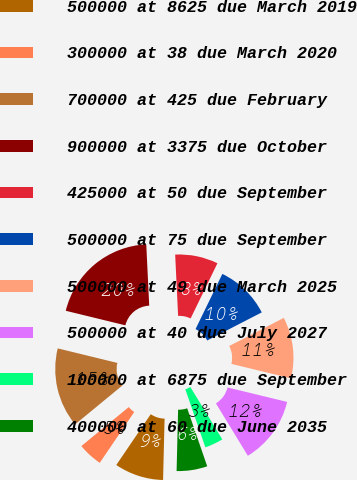<chart> <loc_0><loc_0><loc_500><loc_500><pie_chart><fcel>500000 at 8625 due March 2019<fcel>300000 at 38 due March 2020<fcel>700000 at 425 due February<fcel>900000 at 3375 due October<fcel>425000 at 50 due September<fcel>500000 at 75 due September<fcel>500000 at 49 due March 2025<fcel>500000 at 40 due July 2027<fcel>100000 at 6875 due September<fcel>400000 at 60 due June 2035<nl><fcel>9.09%<fcel>4.56%<fcel>14.76%<fcel>20.43%<fcel>7.96%<fcel>10.23%<fcel>11.36%<fcel>12.49%<fcel>3.42%<fcel>5.69%<nl></chart> 